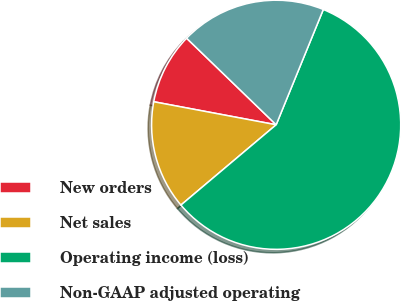<chart> <loc_0><loc_0><loc_500><loc_500><pie_chart><fcel>New orders<fcel>Net sales<fcel>Operating income (loss)<fcel>Non-GAAP adjusted operating<nl><fcel>9.27%<fcel>14.11%<fcel>57.67%<fcel>18.95%<nl></chart> 